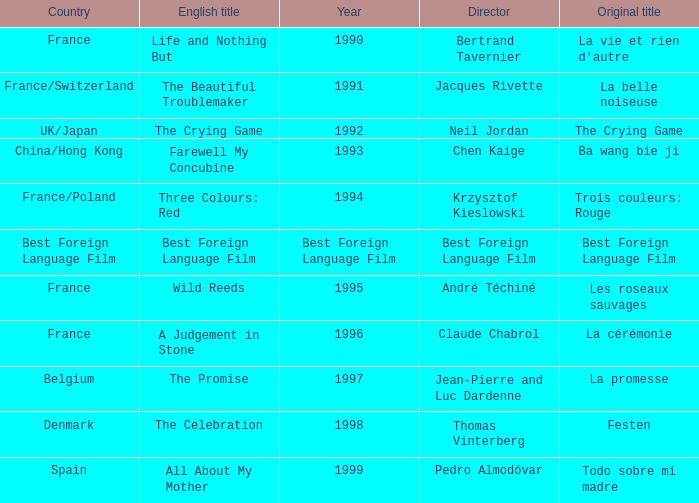What's the English title listed that has an Original title of The Crying Game? The Crying Game. Would you be able to parse every entry in this table? {'header': ['Country', 'English title', 'Year', 'Director', 'Original title'], 'rows': [['France', 'Life and Nothing But', '1990', 'Bertrand Tavernier', "La vie et rien d'autre"], ['France/Switzerland', 'The Beautiful Troublemaker', '1991', 'Jacques Rivette', 'La belle noiseuse'], ['UK/Japan', 'The Crying Game', '1992', 'Neil Jordan', 'The Crying Game'], ['China/Hong Kong', 'Farewell My Concubine', '1993', 'Chen Kaige', 'Ba wang bie ji'], ['France/Poland', 'Three Colours: Red', '1994', 'Krzysztof Kieslowski', 'Trois couleurs: Rouge'], ['Best Foreign Language Film', 'Best Foreign Language Film', 'Best Foreign Language Film', 'Best Foreign Language Film', 'Best Foreign Language Film'], ['France', 'Wild Reeds', '1995', 'André Téchiné', 'Les roseaux sauvages'], ['France', 'A Judgement in Stone', '1996', 'Claude Chabrol', 'La cérémonie'], ['Belgium', 'The Promise', '1997', 'Jean-Pierre and Luc Dardenne', 'La promesse'], ['Denmark', 'The Celebration', '1998', 'Thomas Vinterberg', 'Festen'], ['Spain', 'All About My Mother', '1999', 'Pedro Almodóvar', 'Todo sobre mi madre']]} 